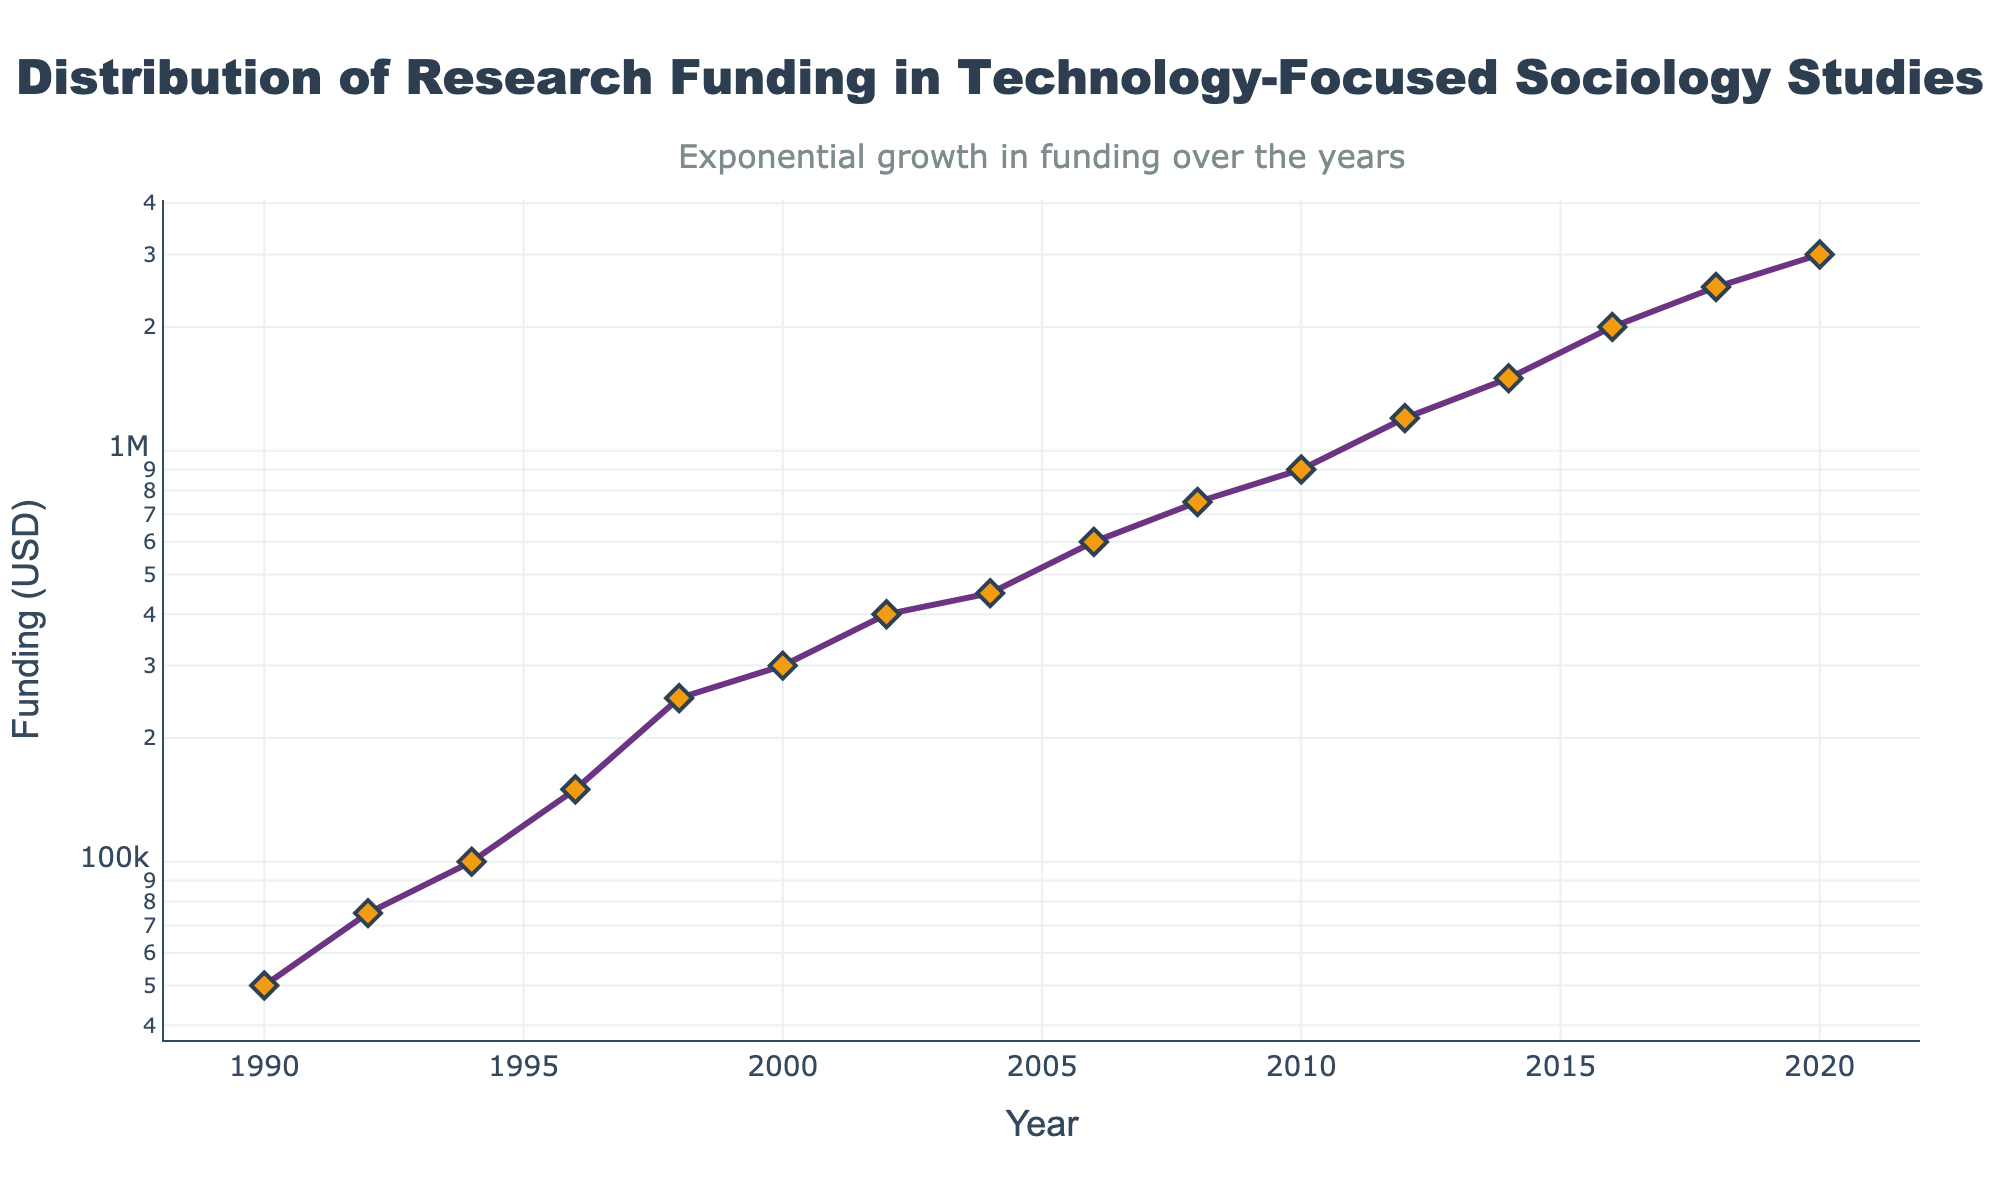what is the title of the figure? The title is located at the top and is centered in the figure, in a large and bold font. It provides an overview of the data being presented. The title states "Distribution of Research Funding in Technology-Focused Sociology Studies."_
Answer: Distribution of Research Funding in Technology-Focused Sociology Studies what is the range of the years displayed on the x-axis? The x-axis spans from the beginning year to the end year as marked by the numerical labels along it. It begins at 1990 and ends at 2020.
Answer: 1990 to 2020 what type of scale is used on the y-axis? The y-axis is presented in a logarithmic scale, which can be identified by the varying intervals and the phrase “log” mentioned in the description.
Answer: Logarithmic scale what is the approximate funding amount in 2008? Locate the data point corresponding to the year 2008. From the y-axis, the point aligns with the value slightly above $750,000.
Answer: $750,000 how many data points are plotted in the figure? Count the markers (diamond shapes) shown on the plot representing each data point. Each marker corresponds to a year with its funding value. There are 16 markers.
Answer: 16 by how much has the funding increased from 1990 to 2000? The funding in 1990 is $50,000 and in 2000 is $300,000. Subtract the initial value from the final value to find the increase. $300,000 - $50,000 = $250,000.
Answer: $250,000 which two consecutive years show the largest increase in funding? Identify the two consecutive years with the largest visual gap between their points on the y-axis. In this case, it's between 2014 ($1,500,000) and 2016 ($2,000,000), showing an increase of $500,000.
Answer: 2014 and 2016 how does the funding trend change around the year 2000? Examine the slope of the line near the year 2000 to understand the trend. Before 2000, the funding was lower and increasing gradually. After 2000, it starts to increase more rapidly.
Answer: Increase becomes rapid what's the approximate average funding amount for the years 2010 to 2020? Add the funding amounts for 2010, 2012, 2014, 2016, 2018, and 2020, then divide by the number of years. (900,000 + 1,200,000 + 1,500,000 + 2,000,000 + 2,500,000 + 3,000,000) / 6 ≈ 1,850,000.
Answer: $1,850,000 what annotation is included in the figure? Check for text annotations placed alongside or above the plot, often providing context or additional insights. The annotation states "Exponential growth in funding over the years".
Answer: Exponential growth in funding over the years 